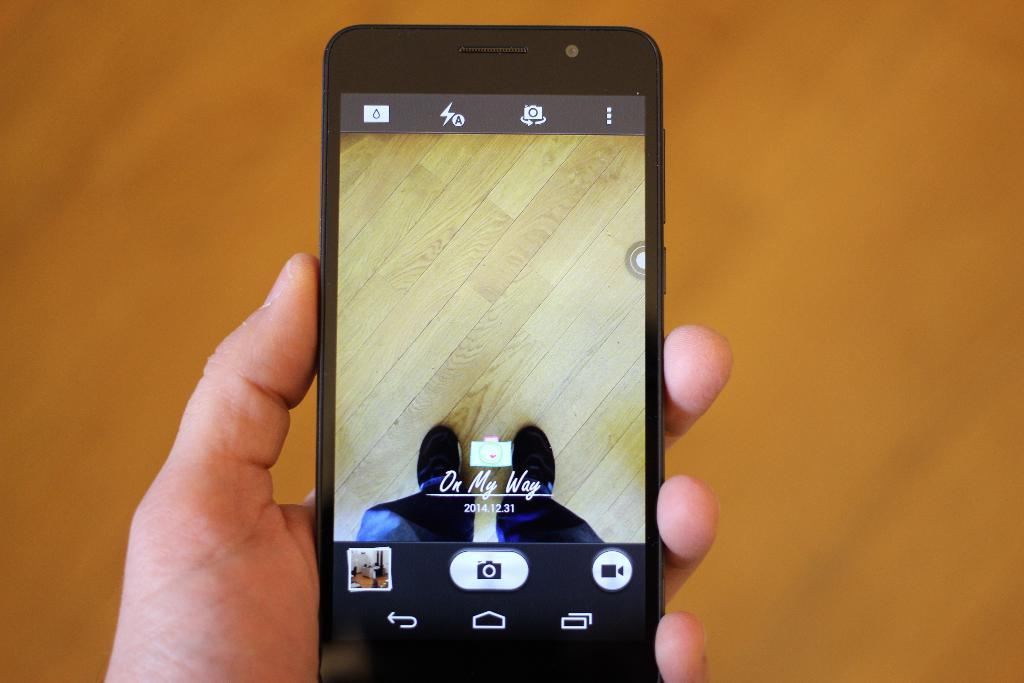<image>
Give a short and clear explanation of the subsequent image. A smart phone on which the words On My Way can be seen. 